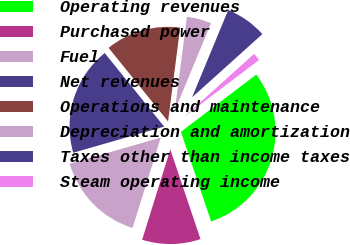Convert chart to OTSL. <chart><loc_0><loc_0><loc_500><loc_500><pie_chart><fcel>Operating revenues<fcel>Purchased power<fcel>Fuel<fcel>Net revenues<fcel>Operations and maintenance<fcel>Depreciation and amortization<fcel>Taxes other than income taxes<fcel>Steam operating income<nl><fcel>30.17%<fcel>9.98%<fcel>15.75%<fcel>18.63%<fcel>12.86%<fcel>4.21%<fcel>7.09%<fcel>1.32%<nl></chart> 